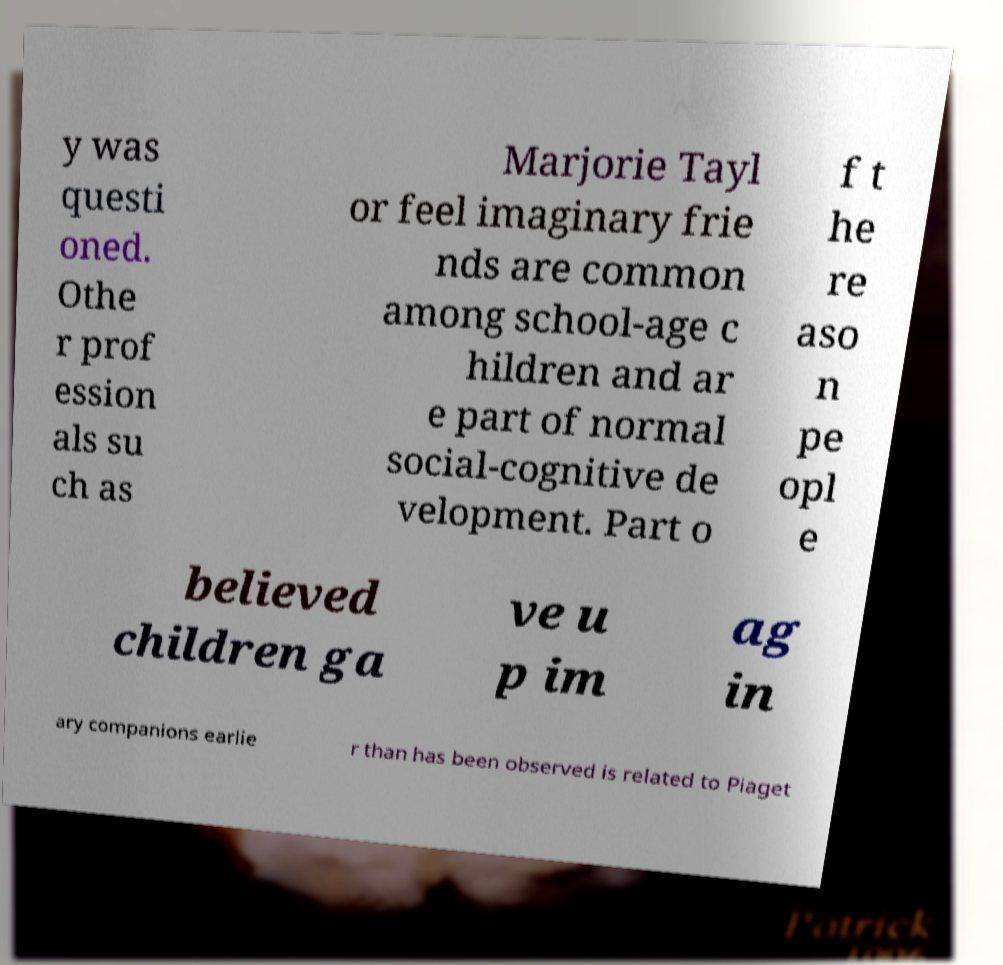Could you assist in decoding the text presented in this image and type it out clearly? y was questi oned. Othe r prof ession als su ch as Marjorie Tayl or feel imaginary frie nds are common among school-age c hildren and ar e part of normal social-cognitive de velopment. Part o f t he re aso n pe opl e believed children ga ve u p im ag in ary companions earlie r than has been observed is related to Piaget 